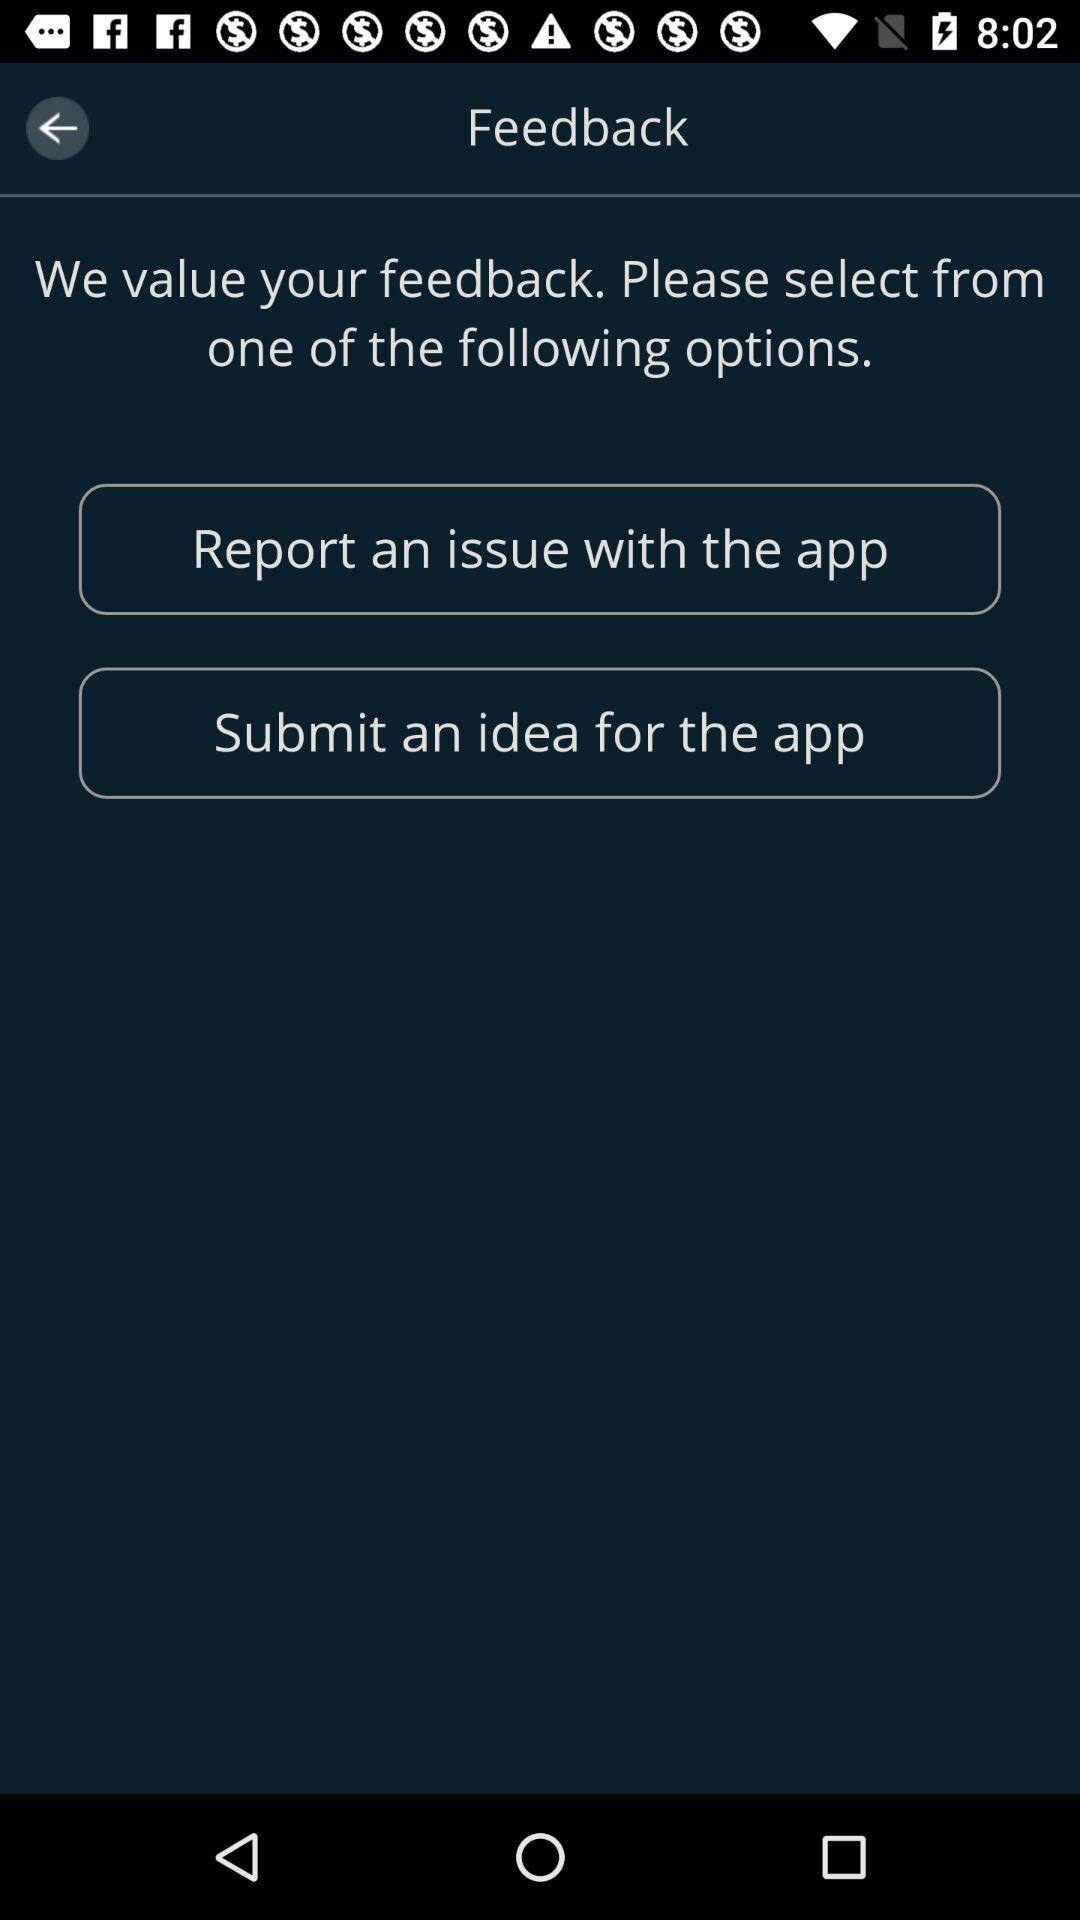Which options are given for feedback? The given options are "Report an issue with the app" and "Submit an idea for the app". 